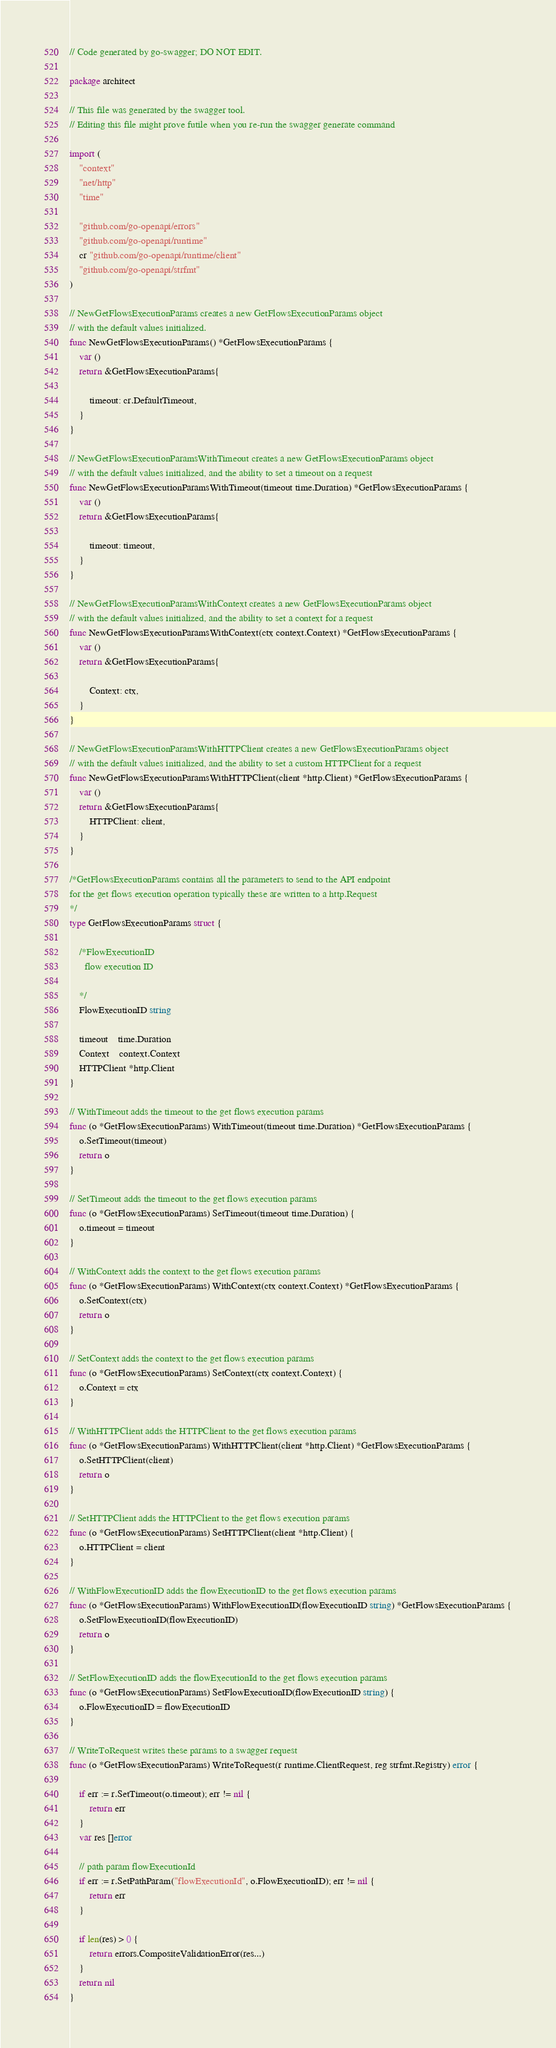<code> <loc_0><loc_0><loc_500><loc_500><_Go_>// Code generated by go-swagger; DO NOT EDIT.

package architect

// This file was generated by the swagger tool.
// Editing this file might prove futile when you re-run the swagger generate command

import (
	"context"
	"net/http"
	"time"

	"github.com/go-openapi/errors"
	"github.com/go-openapi/runtime"
	cr "github.com/go-openapi/runtime/client"
	"github.com/go-openapi/strfmt"
)

// NewGetFlowsExecutionParams creates a new GetFlowsExecutionParams object
// with the default values initialized.
func NewGetFlowsExecutionParams() *GetFlowsExecutionParams {
	var ()
	return &GetFlowsExecutionParams{

		timeout: cr.DefaultTimeout,
	}
}

// NewGetFlowsExecutionParamsWithTimeout creates a new GetFlowsExecutionParams object
// with the default values initialized, and the ability to set a timeout on a request
func NewGetFlowsExecutionParamsWithTimeout(timeout time.Duration) *GetFlowsExecutionParams {
	var ()
	return &GetFlowsExecutionParams{

		timeout: timeout,
	}
}

// NewGetFlowsExecutionParamsWithContext creates a new GetFlowsExecutionParams object
// with the default values initialized, and the ability to set a context for a request
func NewGetFlowsExecutionParamsWithContext(ctx context.Context) *GetFlowsExecutionParams {
	var ()
	return &GetFlowsExecutionParams{

		Context: ctx,
	}
}

// NewGetFlowsExecutionParamsWithHTTPClient creates a new GetFlowsExecutionParams object
// with the default values initialized, and the ability to set a custom HTTPClient for a request
func NewGetFlowsExecutionParamsWithHTTPClient(client *http.Client) *GetFlowsExecutionParams {
	var ()
	return &GetFlowsExecutionParams{
		HTTPClient: client,
	}
}

/*GetFlowsExecutionParams contains all the parameters to send to the API endpoint
for the get flows execution operation typically these are written to a http.Request
*/
type GetFlowsExecutionParams struct {

	/*FlowExecutionID
	  flow execution ID

	*/
	FlowExecutionID string

	timeout    time.Duration
	Context    context.Context
	HTTPClient *http.Client
}

// WithTimeout adds the timeout to the get flows execution params
func (o *GetFlowsExecutionParams) WithTimeout(timeout time.Duration) *GetFlowsExecutionParams {
	o.SetTimeout(timeout)
	return o
}

// SetTimeout adds the timeout to the get flows execution params
func (o *GetFlowsExecutionParams) SetTimeout(timeout time.Duration) {
	o.timeout = timeout
}

// WithContext adds the context to the get flows execution params
func (o *GetFlowsExecutionParams) WithContext(ctx context.Context) *GetFlowsExecutionParams {
	o.SetContext(ctx)
	return o
}

// SetContext adds the context to the get flows execution params
func (o *GetFlowsExecutionParams) SetContext(ctx context.Context) {
	o.Context = ctx
}

// WithHTTPClient adds the HTTPClient to the get flows execution params
func (o *GetFlowsExecutionParams) WithHTTPClient(client *http.Client) *GetFlowsExecutionParams {
	o.SetHTTPClient(client)
	return o
}

// SetHTTPClient adds the HTTPClient to the get flows execution params
func (o *GetFlowsExecutionParams) SetHTTPClient(client *http.Client) {
	o.HTTPClient = client
}

// WithFlowExecutionID adds the flowExecutionID to the get flows execution params
func (o *GetFlowsExecutionParams) WithFlowExecutionID(flowExecutionID string) *GetFlowsExecutionParams {
	o.SetFlowExecutionID(flowExecutionID)
	return o
}

// SetFlowExecutionID adds the flowExecutionId to the get flows execution params
func (o *GetFlowsExecutionParams) SetFlowExecutionID(flowExecutionID string) {
	o.FlowExecutionID = flowExecutionID
}

// WriteToRequest writes these params to a swagger request
func (o *GetFlowsExecutionParams) WriteToRequest(r runtime.ClientRequest, reg strfmt.Registry) error {

	if err := r.SetTimeout(o.timeout); err != nil {
		return err
	}
	var res []error

	// path param flowExecutionId
	if err := r.SetPathParam("flowExecutionId", o.FlowExecutionID); err != nil {
		return err
	}

	if len(res) > 0 {
		return errors.CompositeValidationError(res...)
	}
	return nil
}
</code> 